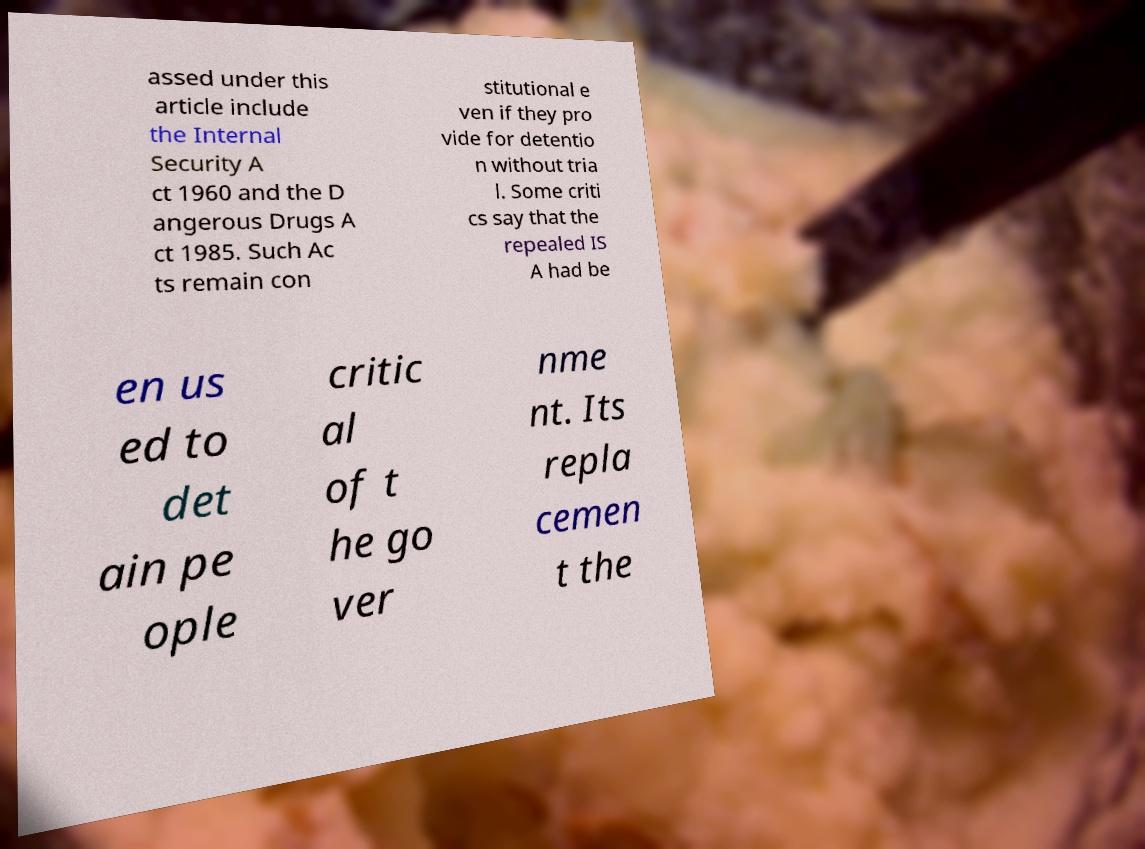For documentation purposes, I need the text within this image transcribed. Could you provide that? assed under this article include the Internal Security A ct 1960 and the D angerous Drugs A ct 1985. Such Ac ts remain con stitutional e ven if they pro vide for detentio n without tria l. Some criti cs say that the repealed IS A had be en us ed to det ain pe ople critic al of t he go ver nme nt. Its repla cemen t the 